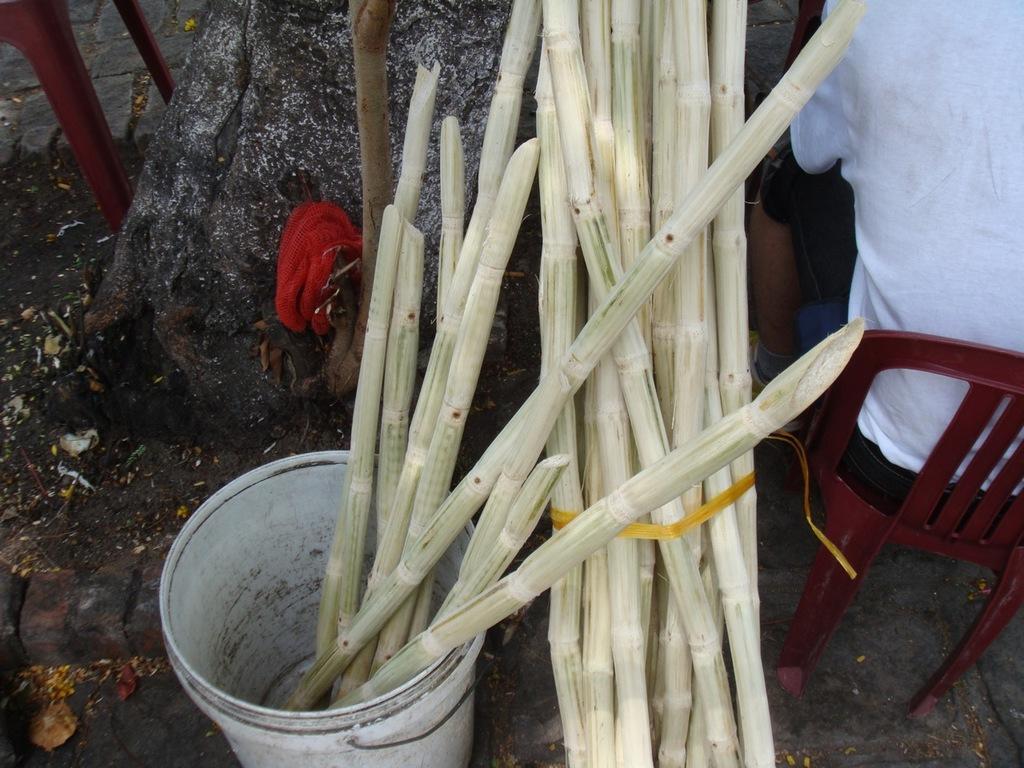Can you describe this image briefly? In the center of the image there are sugar canes. There is a bucket. To the right side of the image there is a person sitting on chair. In the background of the image there is rock. At the bottom of the image there is floor. 